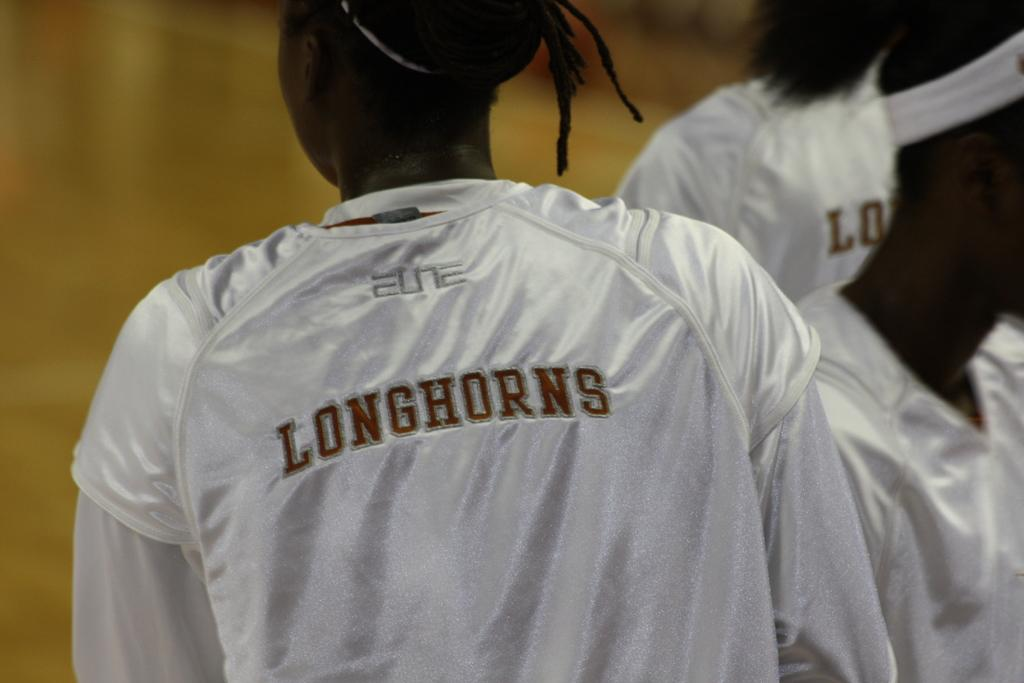<image>
Offer a succinct explanation of the picture presented. A few woman are wearing white Longhorns jerseys. 